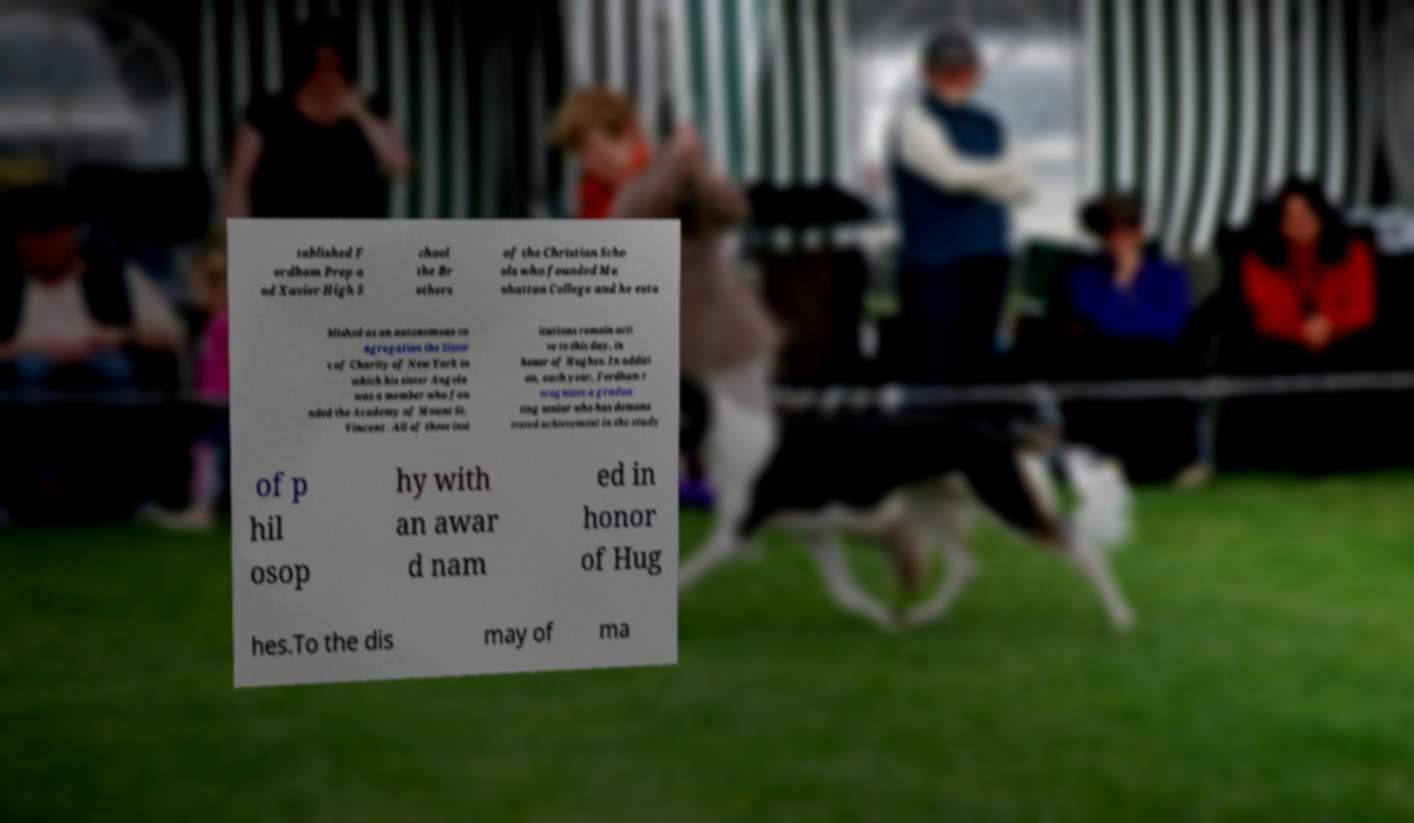I need the written content from this picture converted into text. Can you do that? tablished F ordham Prep a nd Xavier High S chool the Br others of the Christian Scho ols who founded Ma nhattan College and he esta blished as an autonomous co ngregation the Sister s of Charity of New York in which his sister Angela was a member who fou nded the Academy of Mount St. Vincent . All of these inst itutions remain acti ve to this day. in honor of Hughes. In additi on, each year, Fordham r ecognizes a gradua ting senior who has demons trated achievement in the study of p hil osop hy with an awar d nam ed in honor of Hug hes.To the dis may of ma 